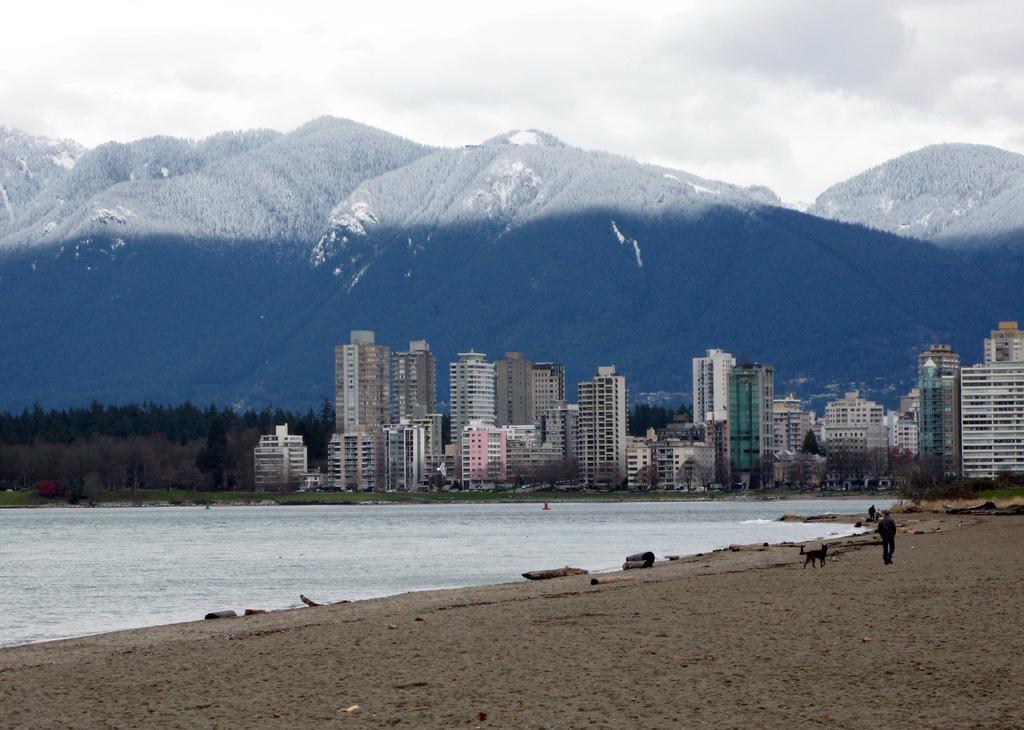How would you summarize this image in a sentence or two? There is a person walking and we can see dog on the sand, water and grass. In the background we can see green grass, trees, buildings, hills and sky with clouds. 